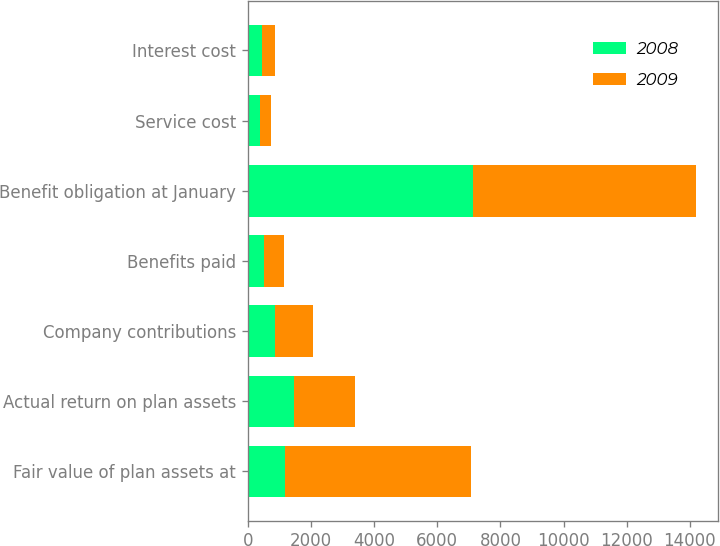<chart> <loc_0><loc_0><loc_500><loc_500><stacked_bar_chart><ecel><fcel>Fair value of plan assets at<fcel>Actual return on plan assets<fcel>Company contributions<fcel>Benefits paid<fcel>Benefit obligation at January<fcel>Service cost<fcel>Interest cost<nl><fcel>2008<fcel>1190.8<fcel>1450.2<fcel>868.7<fcel>511<fcel>7140.1<fcel>398.4<fcel>449.7<nl><fcel>2009<fcel>5887.6<fcel>1959.4<fcel>1190.8<fcel>643.2<fcel>7049.4<fcel>344.1<fcel>414.2<nl></chart> 